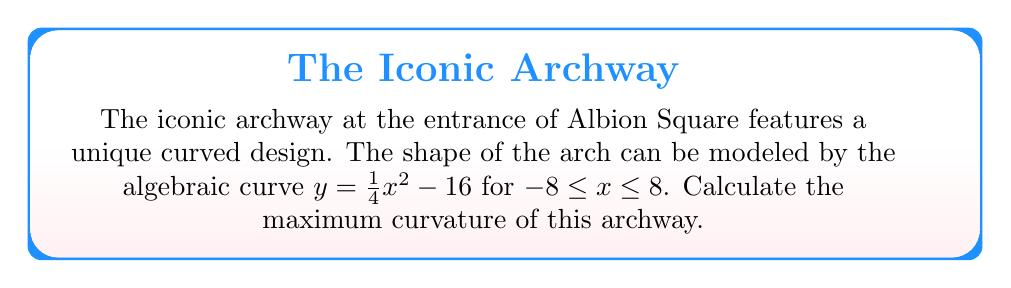Provide a solution to this math problem. To find the maximum curvature of the archway, we'll follow these steps:

1) The curvature $\kappa$ of a curve $y = f(x)$ is given by:

   $$\kappa = \frac{|f''(x)|}{(1 + (f'(x))^2)^{3/2}}$$

2) First, let's find $f'(x)$ and $f''(x)$:
   
   $f'(x) = \frac{1}{2}x$
   $f''(x) = \frac{1}{2}$

3) Substitute these into the curvature formula:

   $$\kappa = \frac{|\frac{1}{2}|}{(1 + (\frac{1}{2}x)^2)^{3/2}}$$

4) Simplify:

   $$\kappa = \frac{1/2}{(1 + \frac{1}{4}x^2)^{3/2}}$$

5) To find the maximum curvature, we need to find where this function is at its maximum. The denominator will be smallest when $x = 0$, which will give us the maximum value for $\kappa$.

6) Evaluate $\kappa$ at $x = 0$:

   $$\kappa_{max} = \frac{1/2}{(1 + 0)^{3/2}} = \frac{1}{2}$$

Therefore, the maximum curvature of the archway is $\frac{1}{2}$.
Answer: $\frac{1}{2}$ 